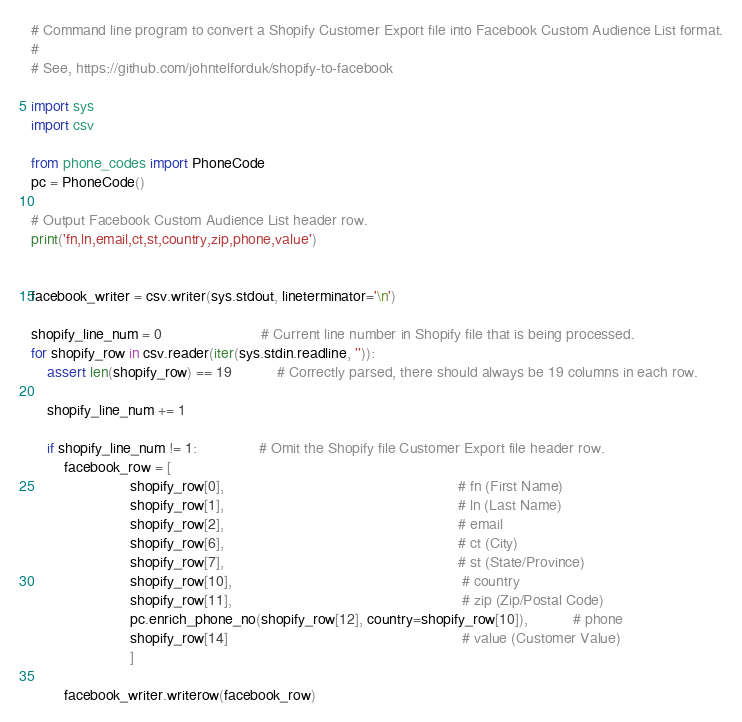<code> <loc_0><loc_0><loc_500><loc_500><_Python_># Command line program to convert a Shopify Customer Export file into Facebook Custom Audience List format.
#
# See, https://github.com/johntelforduk/shopify-to-facebook

import sys
import csv

from phone_codes import PhoneCode
pc = PhoneCode()

# Output Facebook Custom Audience List header row.
print('fn,ln,email,ct,st,country,zip,phone,value')


facebook_writer = csv.writer(sys.stdout, lineterminator='\n')

shopify_line_num = 0                        # Current line number in Shopify file that is being processed.
for shopify_row in csv.reader(iter(sys.stdin.readline, '')):
    assert len(shopify_row) == 19           # Correctly parsed, there should always be 19 columns in each row.

    shopify_line_num += 1

    if shopify_line_num != 1:               # Omit the Shopify file Customer Export file header row.
        facebook_row = [
                        shopify_row[0],                                                         # fn (First Name)
                        shopify_row[1],                                                         # ln (Last Name)
                        shopify_row[2],                                                         # email
                        shopify_row[6],                                                         # ct (City)
                        shopify_row[7],                                                         # st (State/Province)
                        shopify_row[10],                                                        # country
                        shopify_row[11],                                                        # zip (Zip/Postal Code)
                        pc.enrich_phone_no(shopify_row[12], country=shopify_row[10]),           # phone
                        shopify_row[14]                                                         # value (Customer Value)
                        ]

        facebook_writer.writerow(facebook_row)
</code> 